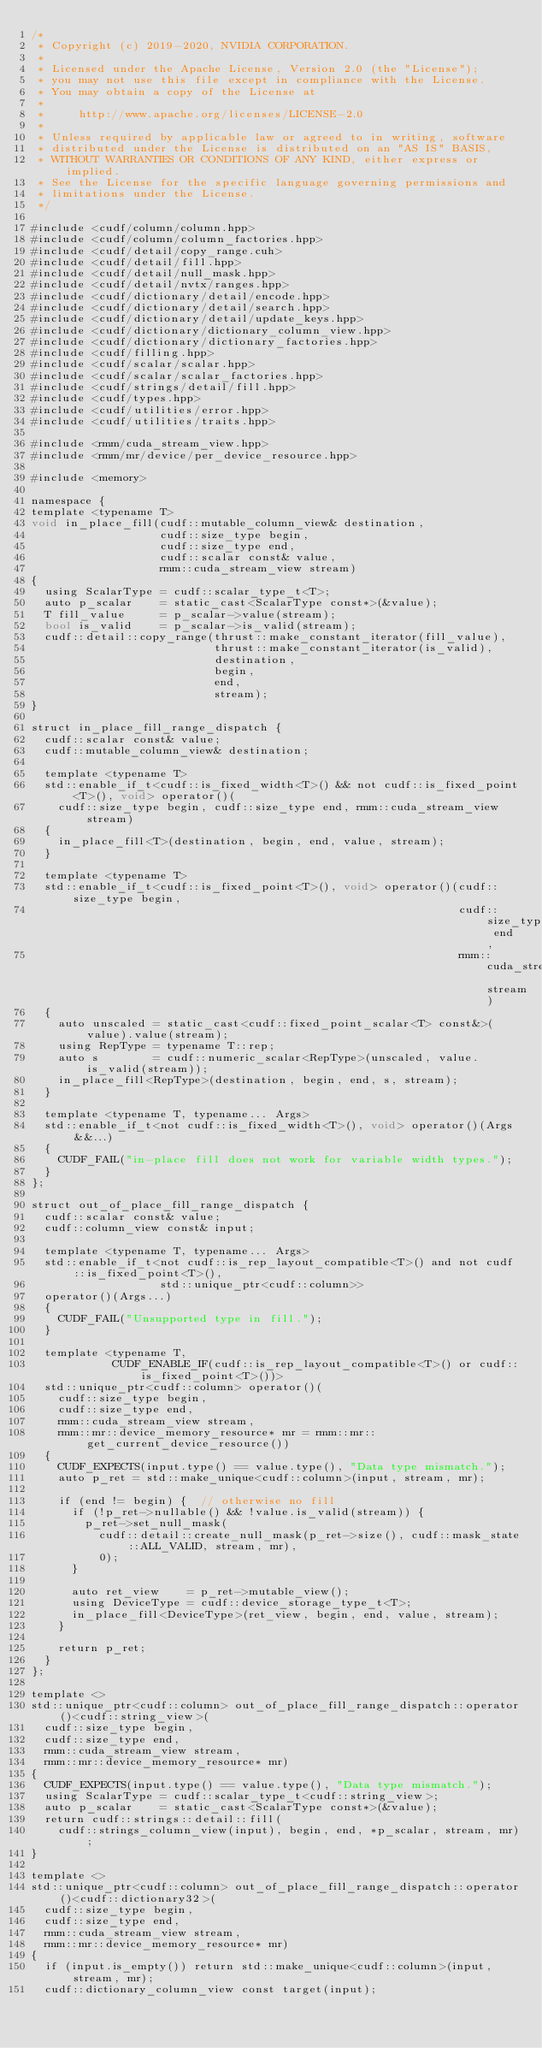<code> <loc_0><loc_0><loc_500><loc_500><_Cuda_>/*
 * Copyright (c) 2019-2020, NVIDIA CORPORATION.
 *
 * Licensed under the Apache License, Version 2.0 (the "License");
 * you may not use this file except in compliance with the License.
 * You may obtain a copy of the License at
 *
 *     http://www.apache.org/licenses/LICENSE-2.0
 *
 * Unless required by applicable law or agreed to in writing, software
 * distributed under the License is distributed on an "AS IS" BASIS,
 * WITHOUT WARRANTIES OR CONDITIONS OF ANY KIND, either express or implied.
 * See the License for the specific language governing permissions and
 * limitations under the License.
 */

#include <cudf/column/column.hpp>
#include <cudf/column/column_factories.hpp>
#include <cudf/detail/copy_range.cuh>
#include <cudf/detail/fill.hpp>
#include <cudf/detail/null_mask.hpp>
#include <cudf/detail/nvtx/ranges.hpp>
#include <cudf/dictionary/detail/encode.hpp>
#include <cudf/dictionary/detail/search.hpp>
#include <cudf/dictionary/detail/update_keys.hpp>
#include <cudf/dictionary/dictionary_column_view.hpp>
#include <cudf/dictionary/dictionary_factories.hpp>
#include <cudf/filling.hpp>
#include <cudf/scalar/scalar.hpp>
#include <cudf/scalar/scalar_factories.hpp>
#include <cudf/strings/detail/fill.hpp>
#include <cudf/types.hpp>
#include <cudf/utilities/error.hpp>
#include <cudf/utilities/traits.hpp>

#include <rmm/cuda_stream_view.hpp>
#include <rmm/mr/device/per_device_resource.hpp>

#include <memory>

namespace {
template <typename T>
void in_place_fill(cudf::mutable_column_view& destination,
                   cudf::size_type begin,
                   cudf::size_type end,
                   cudf::scalar const& value,
                   rmm::cuda_stream_view stream)
{
  using ScalarType = cudf::scalar_type_t<T>;
  auto p_scalar    = static_cast<ScalarType const*>(&value);
  T fill_value     = p_scalar->value(stream);
  bool is_valid    = p_scalar->is_valid(stream);
  cudf::detail::copy_range(thrust::make_constant_iterator(fill_value),
                           thrust::make_constant_iterator(is_valid),
                           destination,
                           begin,
                           end,
                           stream);
}

struct in_place_fill_range_dispatch {
  cudf::scalar const& value;
  cudf::mutable_column_view& destination;

  template <typename T>
  std::enable_if_t<cudf::is_fixed_width<T>() && not cudf::is_fixed_point<T>(), void> operator()(
    cudf::size_type begin, cudf::size_type end, rmm::cuda_stream_view stream)
  {
    in_place_fill<T>(destination, begin, end, value, stream);
  }

  template <typename T>
  std::enable_if_t<cudf::is_fixed_point<T>(), void> operator()(cudf::size_type begin,
                                                               cudf::size_type end,
                                                               rmm::cuda_stream_view stream)
  {
    auto unscaled = static_cast<cudf::fixed_point_scalar<T> const&>(value).value(stream);
    using RepType = typename T::rep;
    auto s        = cudf::numeric_scalar<RepType>(unscaled, value.is_valid(stream));
    in_place_fill<RepType>(destination, begin, end, s, stream);
  }

  template <typename T, typename... Args>
  std::enable_if_t<not cudf::is_fixed_width<T>(), void> operator()(Args&&...)
  {
    CUDF_FAIL("in-place fill does not work for variable width types.");
  }
};

struct out_of_place_fill_range_dispatch {
  cudf::scalar const& value;
  cudf::column_view const& input;

  template <typename T, typename... Args>
  std::enable_if_t<not cudf::is_rep_layout_compatible<T>() and not cudf::is_fixed_point<T>(),
                   std::unique_ptr<cudf::column>>
  operator()(Args...)
  {
    CUDF_FAIL("Unsupported type in fill.");
  }

  template <typename T,
            CUDF_ENABLE_IF(cudf::is_rep_layout_compatible<T>() or cudf::is_fixed_point<T>())>
  std::unique_ptr<cudf::column> operator()(
    cudf::size_type begin,
    cudf::size_type end,
    rmm::cuda_stream_view stream,
    rmm::mr::device_memory_resource* mr = rmm::mr::get_current_device_resource())
  {
    CUDF_EXPECTS(input.type() == value.type(), "Data type mismatch.");
    auto p_ret = std::make_unique<cudf::column>(input, stream, mr);

    if (end != begin) {  // otherwise no fill
      if (!p_ret->nullable() && !value.is_valid(stream)) {
        p_ret->set_null_mask(
          cudf::detail::create_null_mask(p_ret->size(), cudf::mask_state::ALL_VALID, stream, mr),
          0);
      }

      auto ret_view    = p_ret->mutable_view();
      using DeviceType = cudf::device_storage_type_t<T>;
      in_place_fill<DeviceType>(ret_view, begin, end, value, stream);
    }

    return p_ret;
  }
};

template <>
std::unique_ptr<cudf::column> out_of_place_fill_range_dispatch::operator()<cudf::string_view>(
  cudf::size_type begin,
  cudf::size_type end,
  rmm::cuda_stream_view stream,
  rmm::mr::device_memory_resource* mr)
{
  CUDF_EXPECTS(input.type() == value.type(), "Data type mismatch.");
  using ScalarType = cudf::scalar_type_t<cudf::string_view>;
  auto p_scalar    = static_cast<ScalarType const*>(&value);
  return cudf::strings::detail::fill(
    cudf::strings_column_view(input), begin, end, *p_scalar, stream, mr);
}

template <>
std::unique_ptr<cudf::column> out_of_place_fill_range_dispatch::operator()<cudf::dictionary32>(
  cudf::size_type begin,
  cudf::size_type end,
  rmm::cuda_stream_view stream,
  rmm::mr::device_memory_resource* mr)
{
  if (input.is_empty()) return std::make_unique<cudf::column>(input, stream, mr);
  cudf::dictionary_column_view const target(input);</code> 